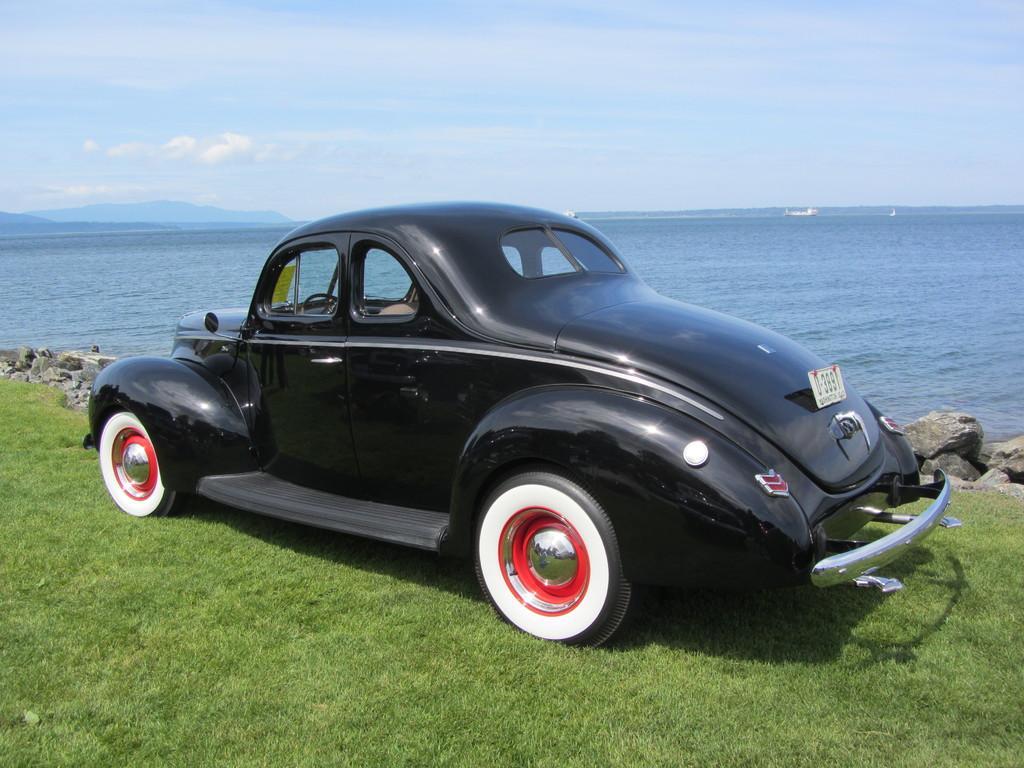How would you summarize this image in a sentence or two? In this image, we can see black car is parked on the grass. Background we can see stones, water, mountains and sky. 